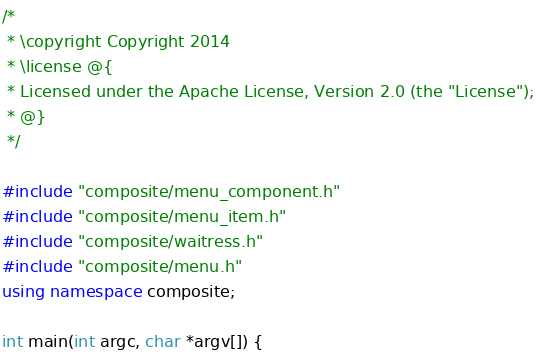Convert code to text. <code><loc_0><loc_0><loc_500><loc_500><_C++_>/*
 * \copyright Copyright 2014
 * \license @{
 * Licensed under the Apache License, Version 2.0 (the "License");
 * @}
 */

#include "composite/menu_component.h"
#include "composite/menu_item.h"
#include "composite/waitress.h"
#include "composite/menu.h"
using namespace composite;

int main(int argc, char *argv[]) {</code> 